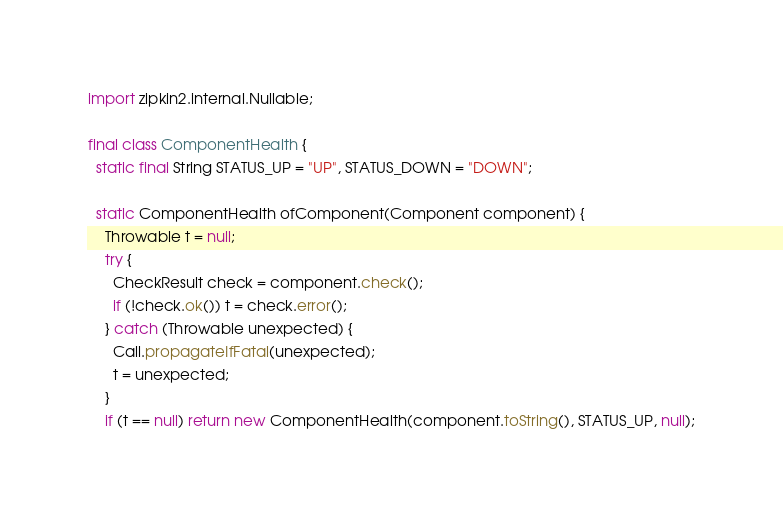Convert code to text. <code><loc_0><loc_0><loc_500><loc_500><_Java_>import zipkin2.internal.Nullable;

final class ComponentHealth {
  static final String STATUS_UP = "UP", STATUS_DOWN = "DOWN";

  static ComponentHealth ofComponent(Component component) {
    Throwable t = null;
    try {
      CheckResult check = component.check();
      if (!check.ok()) t = check.error();
    } catch (Throwable unexpected) {
      Call.propagateIfFatal(unexpected);
      t = unexpected;
    }
    if (t == null) return new ComponentHealth(component.toString(), STATUS_UP, null);</code> 